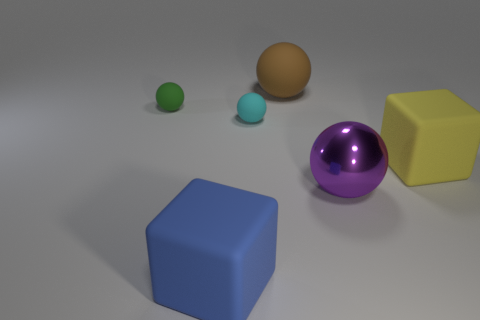Add 3 cyan rubber spheres. How many objects exist? 9 Subtract 1 yellow blocks. How many objects are left? 5 Subtract all blocks. How many objects are left? 4 Subtract 1 balls. How many balls are left? 3 Subtract all brown balls. Subtract all yellow cylinders. How many balls are left? 3 Subtract all red cylinders. How many red spheres are left? 0 Subtract all gray cylinders. Subtract all shiny balls. How many objects are left? 5 Add 5 small rubber objects. How many small rubber objects are left? 7 Add 6 purple things. How many purple things exist? 7 Subtract all cyan balls. How many balls are left? 3 